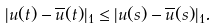<formula> <loc_0><loc_0><loc_500><loc_500>| u ( t ) - \overline { u } ( t ) | _ { 1 } \leq | u ( s ) - \overline { u } ( s ) | _ { 1 } .</formula> 